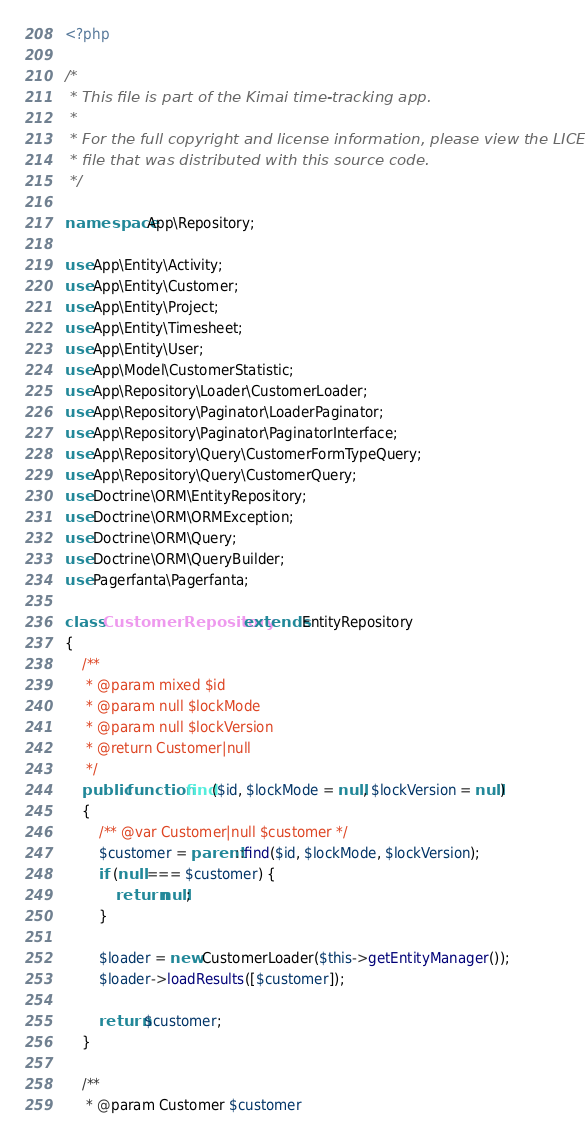<code> <loc_0><loc_0><loc_500><loc_500><_PHP_><?php

/*
 * This file is part of the Kimai time-tracking app.
 *
 * For the full copyright and license information, please view the LICENSE
 * file that was distributed with this source code.
 */

namespace App\Repository;

use App\Entity\Activity;
use App\Entity\Customer;
use App\Entity\Project;
use App\Entity\Timesheet;
use App\Entity\User;
use App\Model\CustomerStatistic;
use App\Repository\Loader\CustomerLoader;
use App\Repository\Paginator\LoaderPaginator;
use App\Repository\Paginator\PaginatorInterface;
use App\Repository\Query\CustomerFormTypeQuery;
use App\Repository\Query\CustomerQuery;
use Doctrine\ORM\EntityRepository;
use Doctrine\ORM\ORMException;
use Doctrine\ORM\Query;
use Doctrine\ORM\QueryBuilder;
use Pagerfanta\Pagerfanta;

class CustomerRepository extends EntityRepository
{
    /**
     * @param mixed $id
     * @param null $lockMode
     * @param null $lockVersion
     * @return Customer|null
     */
    public function find($id, $lockMode = null, $lockVersion = null)
    {
        /** @var Customer|null $customer */
        $customer = parent::find($id, $lockMode, $lockVersion);
        if (null === $customer) {
            return null;
        }

        $loader = new CustomerLoader($this->getEntityManager());
        $loader->loadResults([$customer]);

        return $customer;
    }

    /**
     * @param Customer $customer</code> 